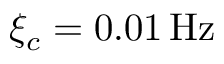Convert formula to latex. <formula><loc_0><loc_0><loc_500><loc_500>\xi _ { c } = 0 . 0 1 \, H z</formula> 